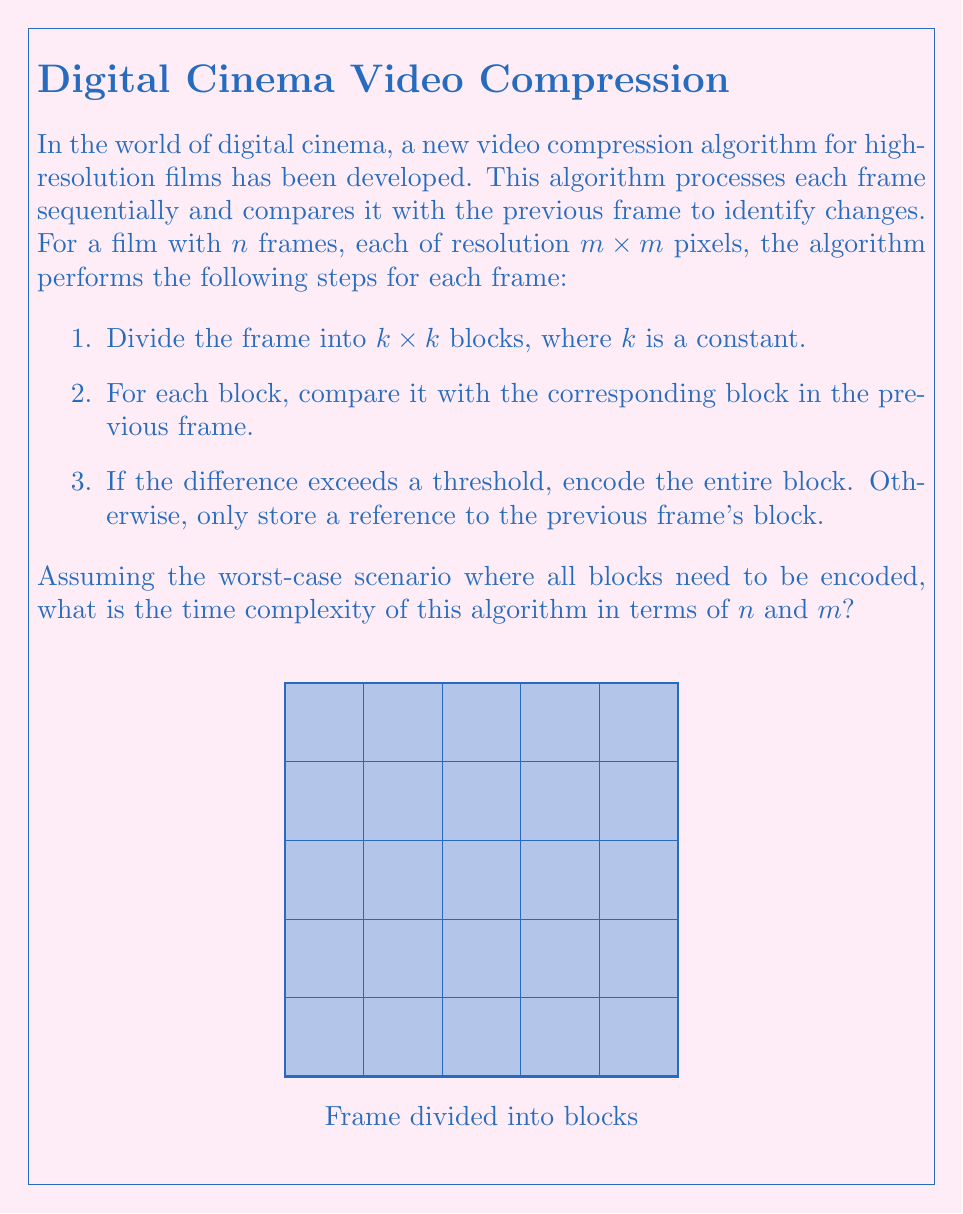Can you solve this math problem? Let's analyze the algorithm step by step:

1. The film has $n$ frames, each with a resolution of $m \times m$ pixels.

2. Each frame is divided into blocks of size $k \times k$. The number of blocks per frame is:

   $$\text{Blocks per frame} = \frac{m}{k} \times \frac{m}{k} = \frac{m^2}{k^2}$$

3. For each block, we perform a comparison with the corresponding block in the previous frame. This comparison takes constant time, let's call it $c$.

4. In the worst-case scenario, all blocks need to be encoded. The encoding process for each block takes time proportional to the number of pixels in the block, which is $k^2$.

5. For each frame, we perform these operations on all blocks:

   $$\text{Time per frame} = \frac{m^2}{k^2} \times (c + k^2) = m^2 \times (\frac{c}{k^2} + 1)$$

6. We repeat this process for all $n$ frames:

   $$\text{Total time} = n \times m^2 \times (\frac{c}{k^2} + 1)$$

7. Since $k$ and $c$ are constants, we can simplify this to:

   $$\text{Total time} = O(n m^2)$$

Therefore, the time complexity of this algorithm is $O(n m^2)$, which is quadratic in terms of the frame resolution and linear in terms of the number of frames.
Answer: $O(n m^2)$ 